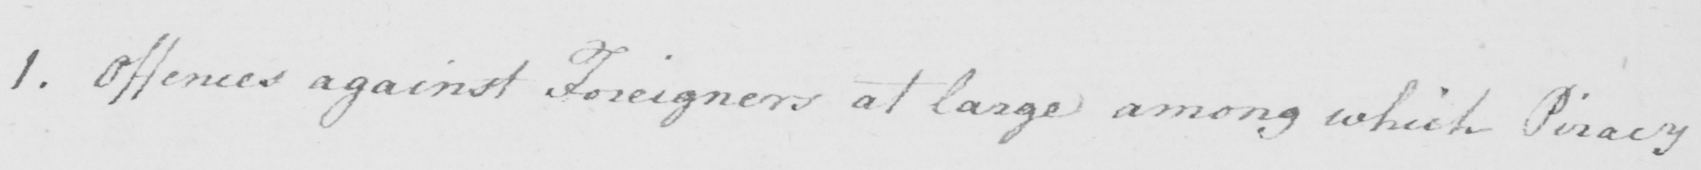What does this handwritten line say? 1 . Offences against Foreigners at large among which Piracy 